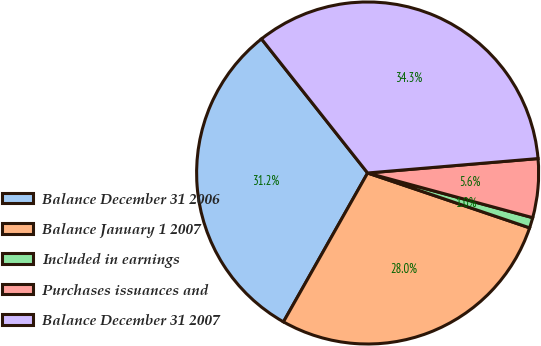<chart> <loc_0><loc_0><loc_500><loc_500><pie_chart><fcel>Balance December 31 2006<fcel>Balance January 1 2007<fcel>Included in earnings<fcel>Purchases issuances and<fcel>Balance December 31 2007<nl><fcel>31.15%<fcel>27.99%<fcel>0.99%<fcel>5.55%<fcel>34.31%<nl></chart> 